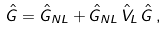Convert formula to latex. <formula><loc_0><loc_0><loc_500><loc_500>\hat { G } = \hat { G } _ { N L } + \hat { G } _ { N L } \, \hat { V } _ { L } \, \hat { G } \, ,</formula> 